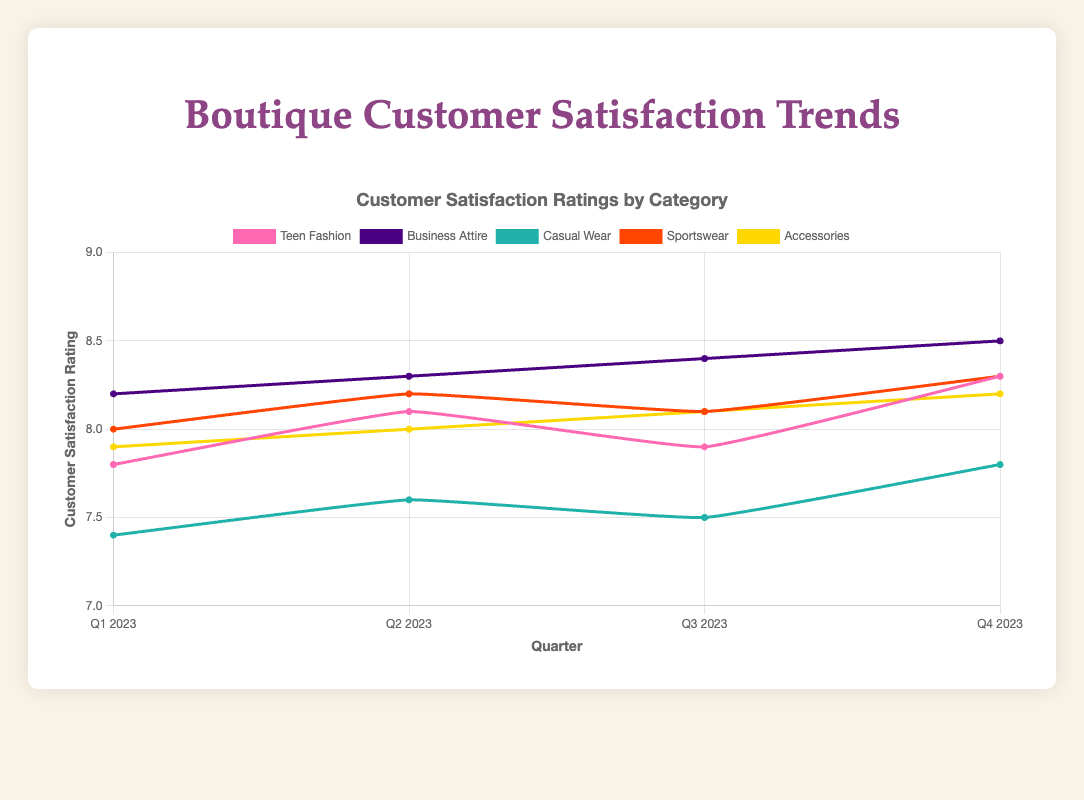What quarter had the highest customer satisfaction rating for Casual Wear? Look at the line representing Casual Wear on the plot and find the quarter with the highest value on the y-axis. The highest rating for Casual Wear is in Q4 2023.
Answer: Q4 2023 Which category showed the most consistent satisfaction ratings throughout the year? Analyze the lines to see which one has the least variation across quarters. Business Attire has slight increases each quarter without any significant dips.
Answer: Business Attire How did the satisfaction rating for Teen Fashion change from Q1 to Q4 2023? Subtract the Q1 rating from the Q4 rating for Teen Fashion. The change is 8.3 - 7.8 = 0.5.
Answer: Increased by 0.5 Which quarter shows the highest overall customer satisfaction rating across all categories? Find the quarter where the combined satisfaction ratings for all categories are highest. Sum the ratings for each quarter and Q4 2023 has the highest total.
Answer: Q4 2023 Which category had the largest increase in satisfaction rating from Q1 to Q2 2023? Calculate the difference in satisfaction ratings for each category between Q1 and Q2 2023, then find the largest difference. The largest increase is in Teen Fashion with an increase of 8.1 - 7.8 = 0.3.
Answer: Teen Fashion What is the average customer satisfaction rating for Sportswear in 2023? Sum all the quarterly ratings for Sportswear and divide by 4. The average is (8.0 + 8.2 + 8.1 + 8.3) / 4 = 8.15.
Answer: 8.15 Compare the satisfaction rating trends between Business Attire and Accessories. Which one showed more improvement? Look at the changes in satisfaction rating from Q1 to Q4 for each category. Business Attire has a change of 8.5 - 8.2 = 0.3, and Accessories have a change of 8.2 - 7.9 = 0.3. Both categories showed the same improvement.
Answer: Both showed the same improvement During which quarter were satisfaction ratings for all categories closest together? Examine each quarter to see the range of ratings for that quarter. Q1 2023 has the ratings closest together with the smallest range from 7.4 to 8.2.
Answer: Q1 2023 What trend can be observed for satisfaction ratings in Casual Wear over the quarters? Look at the line for Casual Wear. The trend shows a slight increase from Q1 to Q2, a slight dip in Q3, and an increase again in Q4.
Answer: Mixed with increases and decreases 